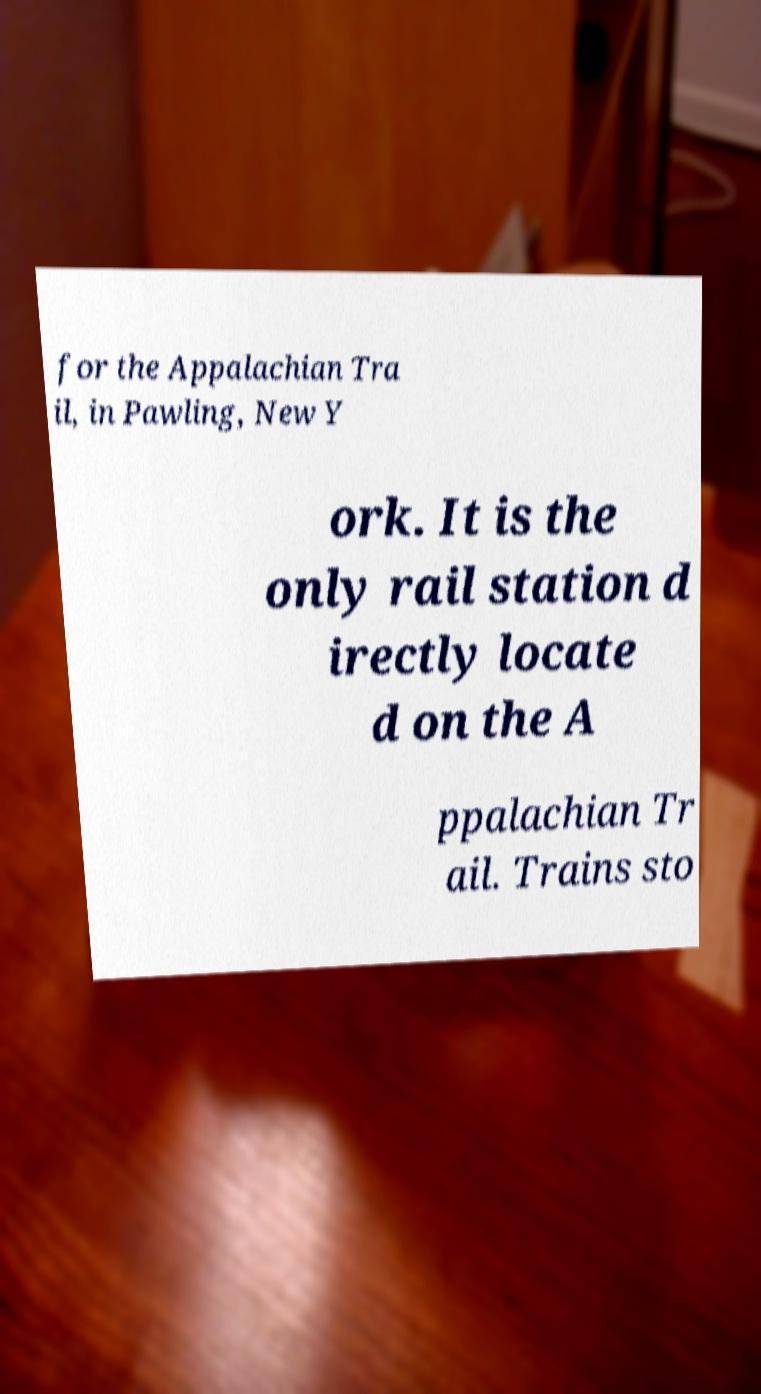Could you assist in decoding the text presented in this image and type it out clearly? for the Appalachian Tra il, in Pawling, New Y ork. It is the only rail station d irectly locate d on the A ppalachian Tr ail. Trains sto 